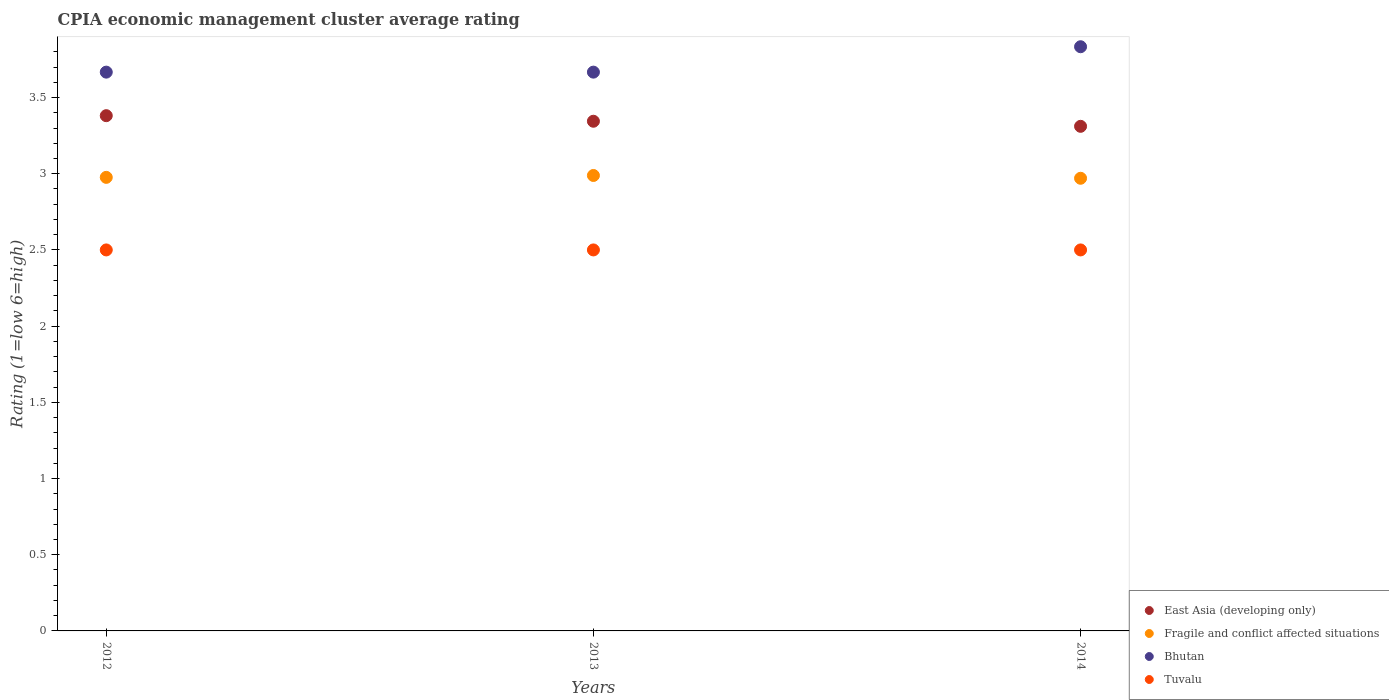Is the number of dotlines equal to the number of legend labels?
Give a very brief answer. Yes. What is the CPIA rating in Bhutan in 2012?
Keep it short and to the point. 3.67. Across all years, what is the maximum CPIA rating in Bhutan?
Your answer should be compact. 3.83. Across all years, what is the minimum CPIA rating in East Asia (developing only)?
Provide a succinct answer. 3.31. What is the total CPIA rating in Tuvalu in the graph?
Offer a terse response. 7.5. What is the difference between the CPIA rating in Fragile and conflict affected situations in 2014 and the CPIA rating in Tuvalu in 2012?
Your answer should be compact. 0.47. What is the average CPIA rating in Bhutan per year?
Your response must be concise. 3.72. In the year 2012, what is the difference between the CPIA rating in Tuvalu and CPIA rating in East Asia (developing only)?
Give a very brief answer. -0.88. In how many years, is the CPIA rating in Bhutan greater than 0.7?
Provide a short and direct response. 3. What is the ratio of the CPIA rating in East Asia (developing only) in 2012 to that in 2013?
Your answer should be very brief. 1.01. Is the CPIA rating in Tuvalu in 2013 less than that in 2014?
Your response must be concise. No. Is the difference between the CPIA rating in Tuvalu in 2013 and 2014 greater than the difference between the CPIA rating in East Asia (developing only) in 2013 and 2014?
Your response must be concise. No. What is the difference between the highest and the second highest CPIA rating in Bhutan?
Your answer should be compact. 0.17. What is the difference between the highest and the lowest CPIA rating in East Asia (developing only)?
Your response must be concise. 0.07. In how many years, is the CPIA rating in Fragile and conflict affected situations greater than the average CPIA rating in Fragile and conflict affected situations taken over all years?
Offer a terse response. 1. Is the sum of the CPIA rating in Tuvalu in 2013 and 2014 greater than the maximum CPIA rating in East Asia (developing only) across all years?
Keep it short and to the point. Yes. How many dotlines are there?
Provide a short and direct response. 4. How many years are there in the graph?
Offer a very short reply. 3. Does the graph contain grids?
Your answer should be compact. No. What is the title of the graph?
Your answer should be compact. CPIA economic management cluster average rating. Does "United States" appear as one of the legend labels in the graph?
Your response must be concise. No. What is the label or title of the X-axis?
Your response must be concise. Years. What is the label or title of the Y-axis?
Provide a succinct answer. Rating (1=low 6=high). What is the Rating (1=low 6=high) in East Asia (developing only) in 2012?
Make the answer very short. 3.38. What is the Rating (1=low 6=high) in Fragile and conflict affected situations in 2012?
Provide a short and direct response. 2.98. What is the Rating (1=low 6=high) of Bhutan in 2012?
Your answer should be compact. 3.67. What is the Rating (1=low 6=high) of Tuvalu in 2012?
Your answer should be compact. 2.5. What is the Rating (1=low 6=high) of East Asia (developing only) in 2013?
Offer a very short reply. 3.34. What is the Rating (1=low 6=high) in Fragile and conflict affected situations in 2013?
Ensure brevity in your answer.  2.99. What is the Rating (1=low 6=high) in Bhutan in 2013?
Your response must be concise. 3.67. What is the Rating (1=low 6=high) in Tuvalu in 2013?
Offer a very short reply. 2.5. What is the Rating (1=low 6=high) in East Asia (developing only) in 2014?
Give a very brief answer. 3.31. What is the Rating (1=low 6=high) in Fragile and conflict affected situations in 2014?
Provide a short and direct response. 2.97. What is the Rating (1=low 6=high) in Bhutan in 2014?
Make the answer very short. 3.83. What is the Rating (1=low 6=high) of Tuvalu in 2014?
Your answer should be very brief. 2.5. Across all years, what is the maximum Rating (1=low 6=high) of East Asia (developing only)?
Your answer should be very brief. 3.38. Across all years, what is the maximum Rating (1=low 6=high) of Fragile and conflict affected situations?
Make the answer very short. 2.99. Across all years, what is the maximum Rating (1=low 6=high) of Bhutan?
Keep it short and to the point. 3.83. Across all years, what is the minimum Rating (1=low 6=high) of East Asia (developing only)?
Make the answer very short. 3.31. Across all years, what is the minimum Rating (1=low 6=high) of Fragile and conflict affected situations?
Keep it short and to the point. 2.97. Across all years, what is the minimum Rating (1=low 6=high) in Bhutan?
Your answer should be very brief. 3.67. Across all years, what is the minimum Rating (1=low 6=high) of Tuvalu?
Provide a short and direct response. 2.5. What is the total Rating (1=low 6=high) of East Asia (developing only) in the graph?
Offer a terse response. 10.04. What is the total Rating (1=low 6=high) in Fragile and conflict affected situations in the graph?
Offer a very short reply. 8.93. What is the total Rating (1=low 6=high) of Bhutan in the graph?
Ensure brevity in your answer.  11.17. What is the total Rating (1=low 6=high) of Tuvalu in the graph?
Keep it short and to the point. 7.5. What is the difference between the Rating (1=low 6=high) in East Asia (developing only) in 2012 and that in 2013?
Your answer should be compact. 0.04. What is the difference between the Rating (1=low 6=high) of Fragile and conflict affected situations in 2012 and that in 2013?
Offer a very short reply. -0.01. What is the difference between the Rating (1=low 6=high) in Bhutan in 2012 and that in 2013?
Offer a terse response. 0. What is the difference between the Rating (1=low 6=high) in East Asia (developing only) in 2012 and that in 2014?
Offer a very short reply. 0.07. What is the difference between the Rating (1=low 6=high) in Fragile and conflict affected situations in 2012 and that in 2014?
Keep it short and to the point. 0.01. What is the difference between the Rating (1=low 6=high) of East Asia (developing only) in 2013 and that in 2014?
Your answer should be very brief. 0.03. What is the difference between the Rating (1=low 6=high) of Fragile and conflict affected situations in 2013 and that in 2014?
Your answer should be compact. 0.02. What is the difference between the Rating (1=low 6=high) of East Asia (developing only) in 2012 and the Rating (1=low 6=high) of Fragile and conflict affected situations in 2013?
Make the answer very short. 0.39. What is the difference between the Rating (1=low 6=high) of East Asia (developing only) in 2012 and the Rating (1=low 6=high) of Bhutan in 2013?
Provide a succinct answer. -0.29. What is the difference between the Rating (1=low 6=high) of East Asia (developing only) in 2012 and the Rating (1=low 6=high) of Tuvalu in 2013?
Give a very brief answer. 0.88. What is the difference between the Rating (1=low 6=high) in Fragile and conflict affected situations in 2012 and the Rating (1=low 6=high) in Bhutan in 2013?
Provide a succinct answer. -0.69. What is the difference between the Rating (1=low 6=high) of Fragile and conflict affected situations in 2012 and the Rating (1=low 6=high) of Tuvalu in 2013?
Give a very brief answer. 0.48. What is the difference between the Rating (1=low 6=high) of Bhutan in 2012 and the Rating (1=low 6=high) of Tuvalu in 2013?
Keep it short and to the point. 1.17. What is the difference between the Rating (1=low 6=high) of East Asia (developing only) in 2012 and the Rating (1=low 6=high) of Fragile and conflict affected situations in 2014?
Ensure brevity in your answer.  0.41. What is the difference between the Rating (1=low 6=high) in East Asia (developing only) in 2012 and the Rating (1=low 6=high) in Bhutan in 2014?
Your answer should be compact. -0.45. What is the difference between the Rating (1=low 6=high) in East Asia (developing only) in 2012 and the Rating (1=low 6=high) in Tuvalu in 2014?
Provide a short and direct response. 0.88. What is the difference between the Rating (1=low 6=high) in Fragile and conflict affected situations in 2012 and the Rating (1=low 6=high) in Bhutan in 2014?
Offer a very short reply. -0.86. What is the difference between the Rating (1=low 6=high) in Fragile and conflict affected situations in 2012 and the Rating (1=low 6=high) in Tuvalu in 2014?
Keep it short and to the point. 0.48. What is the difference between the Rating (1=low 6=high) of Bhutan in 2012 and the Rating (1=low 6=high) of Tuvalu in 2014?
Offer a terse response. 1.17. What is the difference between the Rating (1=low 6=high) in East Asia (developing only) in 2013 and the Rating (1=low 6=high) in Fragile and conflict affected situations in 2014?
Your response must be concise. 0.37. What is the difference between the Rating (1=low 6=high) of East Asia (developing only) in 2013 and the Rating (1=low 6=high) of Bhutan in 2014?
Ensure brevity in your answer.  -0.49. What is the difference between the Rating (1=low 6=high) of East Asia (developing only) in 2013 and the Rating (1=low 6=high) of Tuvalu in 2014?
Ensure brevity in your answer.  0.84. What is the difference between the Rating (1=low 6=high) of Fragile and conflict affected situations in 2013 and the Rating (1=low 6=high) of Bhutan in 2014?
Your response must be concise. -0.84. What is the difference between the Rating (1=low 6=high) in Fragile and conflict affected situations in 2013 and the Rating (1=low 6=high) in Tuvalu in 2014?
Make the answer very short. 0.49. What is the average Rating (1=low 6=high) in East Asia (developing only) per year?
Your response must be concise. 3.35. What is the average Rating (1=low 6=high) of Fragile and conflict affected situations per year?
Provide a short and direct response. 2.98. What is the average Rating (1=low 6=high) of Bhutan per year?
Make the answer very short. 3.72. In the year 2012, what is the difference between the Rating (1=low 6=high) of East Asia (developing only) and Rating (1=low 6=high) of Fragile and conflict affected situations?
Provide a succinct answer. 0.4. In the year 2012, what is the difference between the Rating (1=low 6=high) of East Asia (developing only) and Rating (1=low 6=high) of Bhutan?
Ensure brevity in your answer.  -0.29. In the year 2012, what is the difference between the Rating (1=low 6=high) in East Asia (developing only) and Rating (1=low 6=high) in Tuvalu?
Your answer should be compact. 0.88. In the year 2012, what is the difference between the Rating (1=low 6=high) of Fragile and conflict affected situations and Rating (1=low 6=high) of Bhutan?
Offer a terse response. -0.69. In the year 2012, what is the difference between the Rating (1=low 6=high) in Fragile and conflict affected situations and Rating (1=low 6=high) in Tuvalu?
Offer a very short reply. 0.48. In the year 2012, what is the difference between the Rating (1=low 6=high) in Bhutan and Rating (1=low 6=high) in Tuvalu?
Give a very brief answer. 1.17. In the year 2013, what is the difference between the Rating (1=low 6=high) in East Asia (developing only) and Rating (1=low 6=high) in Fragile and conflict affected situations?
Keep it short and to the point. 0.36. In the year 2013, what is the difference between the Rating (1=low 6=high) in East Asia (developing only) and Rating (1=low 6=high) in Bhutan?
Provide a short and direct response. -0.32. In the year 2013, what is the difference between the Rating (1=low 6=high) of East Asia (developing only) and Rating (1=low 6=high) of Tuvalu?
Offer a very short reply. 0.84. In the year 2013, what is the difference between the Rating (1=low 6=high) of Fragile and conflict affected situations and Rating (1=low 6=high) of Bhutan?
Ensure brevity in your answer.  -0.68. In the year 2013, what is the difference between the Rating (1=low 6=high) of Fragile and conflict affected situations and Rating (1=low 6=high) of Tuvalu?
Keep it short and to the point. 0.49. In the year 2013, what is the difference between the Rating (1=low 6=high) of Bhutan and Rating (1=low 6=high) of Tuvalu?
Ensure brevity in your answer.  1.17. In the year 2014, what is the difference between the Rating (1=low 6=high) in East Asia (developing only) and Rating (1=low 6=high) in Fragile and conflict affected situations?
Your response must be concise. 0.34. In the year 2014, what is the difference between the Rating (1=low 6=high) of East Asia (developing only) and Rating (1=low 6=high) of Bhutan?
Provide a short and direct response. -0.52. In the year 2014, what is the difference between the Rating (1=low 6=high) in East Asia (developing only) and Rating (1=low 6=high) in Tuvalu?
Offer a very short reply. 0.81. In the year 2014, what is the difference between the Rating (1=low 6=high) of Fragile and conflict affected situations and Rating (1=low 6=high) of Bhutan?
Ensure brevity in your answer.  -0.86. In the year 2014, what is the difference between the Rating (1=low 6=high) in Fragile and conflict affected situations and Rating (1=low 6=high) in Tuvalu?
Make the answer very short. 0.47. In the year 2014, what is the difference between the Rating (1=low 6=high) of Bhutan and Rating (1=low 6=high) of Tuvalu?
Give a very brief answer. 1.33. What is the ratio of the Rating (1=low 6=high) in East Asia (developing only) in 2012 to that in 2013?
Your answer should be compact. 1.01. What is the ratio of the Rating (1=low 6=high) in Bhutan in 2012 to that in 2013?
Ensure brevity in your answer.  1. What is the ratio of the Rating (1=low 6=high) in Tuvalu in 2012 to that in 2013?
Your answer should be compact. 1. What is the ratio of the Rating (1=low 6=high) of East Asia (developing only) in 2012 to that in 2014?
Your answer should be compact. 1.02. What is the ratio of the Rating (1=low 6=high) of Bhutan in 2012 to that in 2014?
Offer a terse response. 0.96. What is the ratio of the Rating (1=low 6=high) of East Asia (developing only) in 2013 to that in 2014?
Offer a terse response. 1.01. What is the ratio of the Rating (1=low 6=high) of Bhutan in 2013 to that in 2014?
Offer a terse response. 0.96. What is the difference between the highest and the second highest Rating (1=low 6=high) in East Asia (developing only)?
Your response must be concise. 0.04. What is the difference between the highest and the second highest Rating (1=low 6=high) of Fragile and conflict affected situations?
Offer a very short reply. 0.01. What is the difference between the highest and the second highest Rating (1=low 6=high) in Bhutan?
Provide a short and direct response. 0.17. What is the difference between the highest and the second highest Rating (1=low 6=high) of Tuvalu?
Your response must be concise. 0. What is the difference between the highest and the lowest Rating (1=low 6=high) in East Asia (developing only)?
Give a very brief answer. 0.07. What is the difference between the highest and the lowest Rating (1=low 6=high) in Fragile and conflict affected situations?
Your answer should be compact. 0.02. What is the difference between the highest and the lowest Rating (1=low 6=high) of Bhutan?
Offer a terse response. 0.17. What is the difference between the highest and the lowest Rating (1=low 6=high) of Tuvalu?
Keep it short and to the point. 0. 